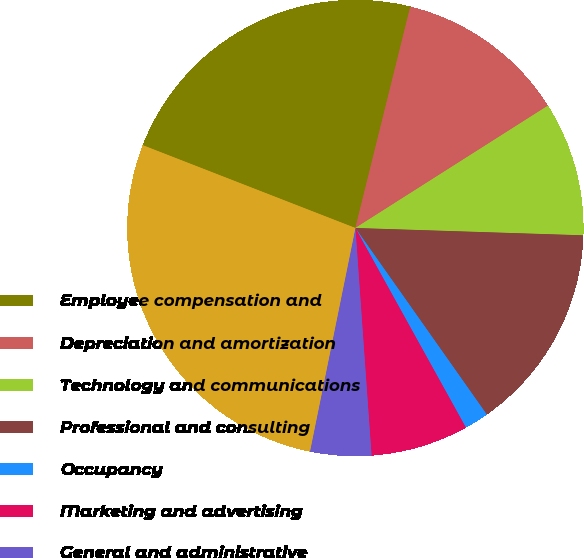Convert chart. <chart><loc_0><loc_0><loc_500><loc_500><pie_chart><fcel>Employee compensation and<fcel>Depreciation and amortization<fcel>Technology and communications<fcel>Professional and consulting<fcel>Occupancy<fcel>Marketing and advertising<fcel>General and administrative<fcel>Total expenses<nl><fcel>22.96%<fcel>12.12%<fcel>9.52%<fcel>14.72%<fcel>1.72%<fcel>6.92%<fcel>4.32%<fcel>27.72%<nl></chart> 